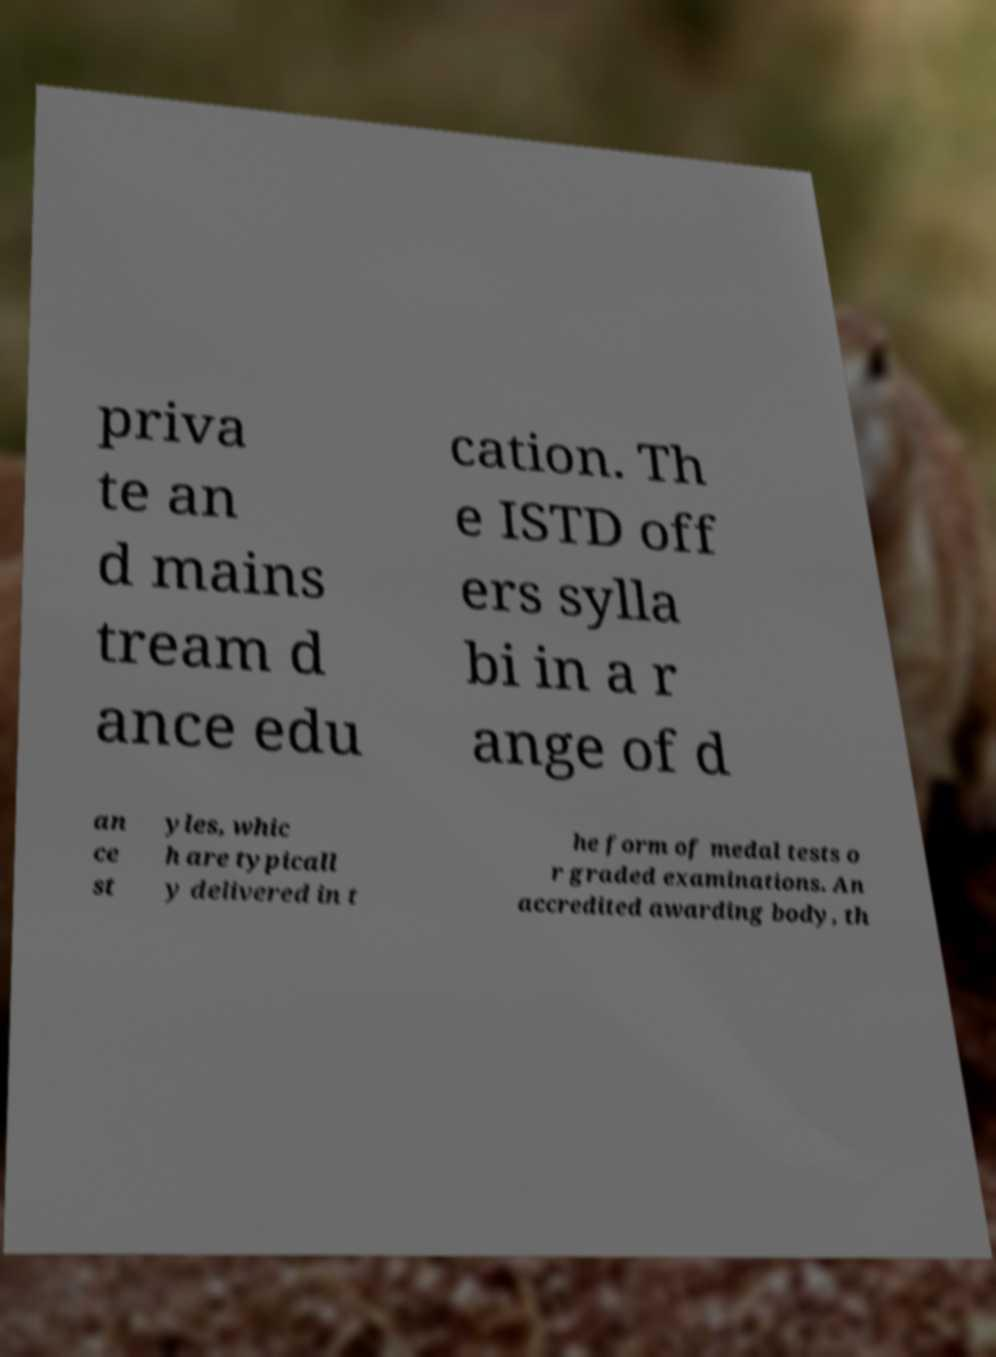What messages or text are displayed in this image? I need them in a readable, typed format. priva te an d mains tream d ance edu cation. Th e ISTD off ers sylla bi in a r ange of d an ce st yles, whic h are typicall y delivered in t he form of medal tests o r graded examinations. An accredited awarding body, th 